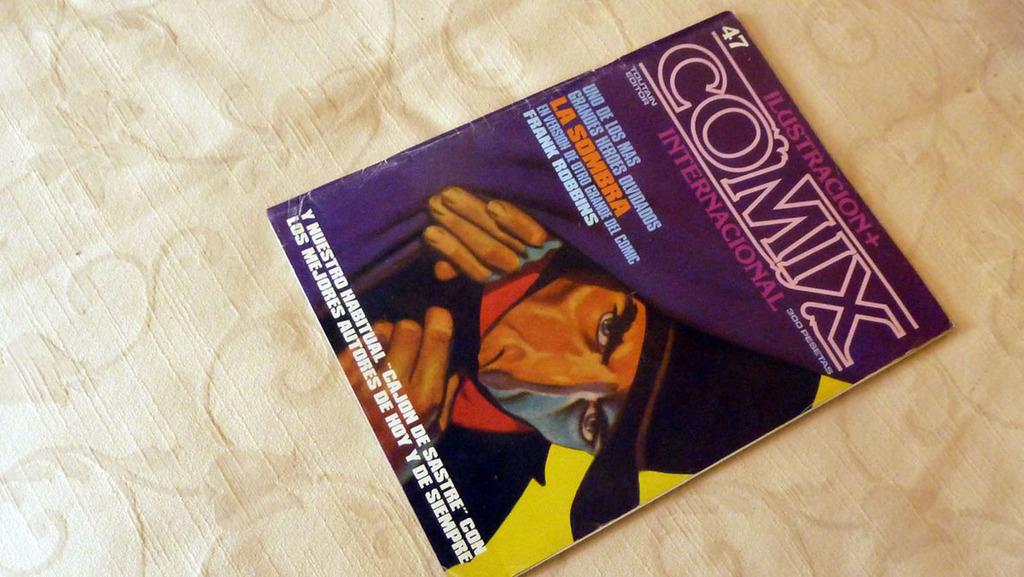What is the title of magazine?
Give a very brief answer. Comix. What issue number is the magazine?
Your answer should be compact. 47. 